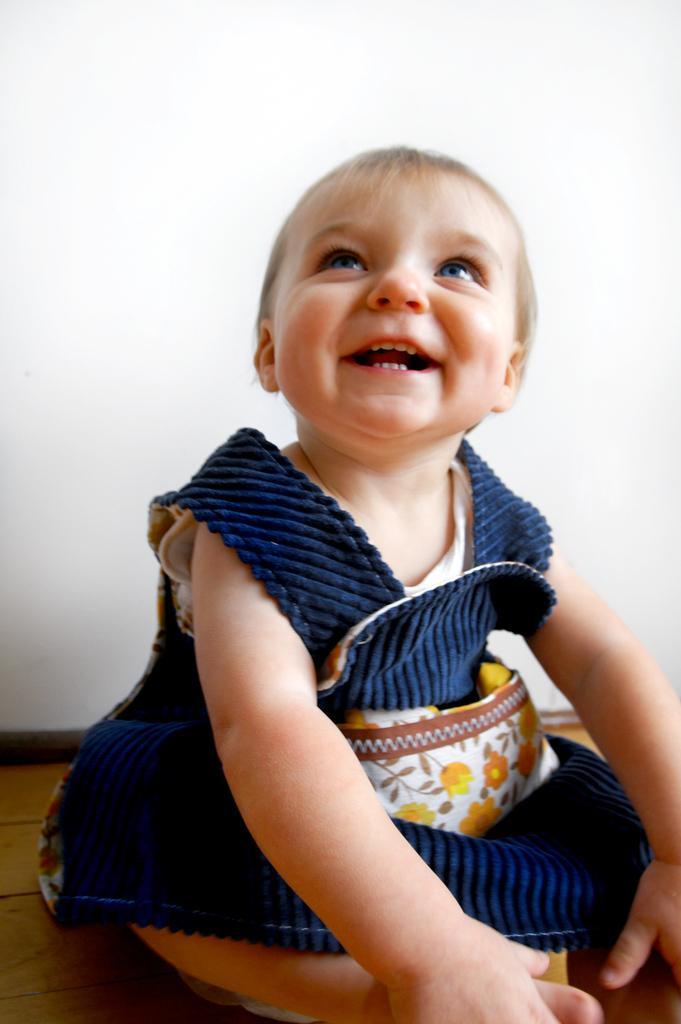In one or two sentences, can you explain what this image depicts? In the picture I can see a baby wearing blue color frock is sitting on the wooden surface and smiling. In the background, we can see the white color wall. 